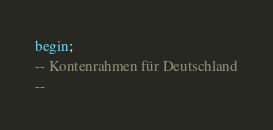<code> <loc_0><loc_0><loc_500><loc_500><_SQL_>begin;
-- Kontenrahmen für Deutschland
--</code> 